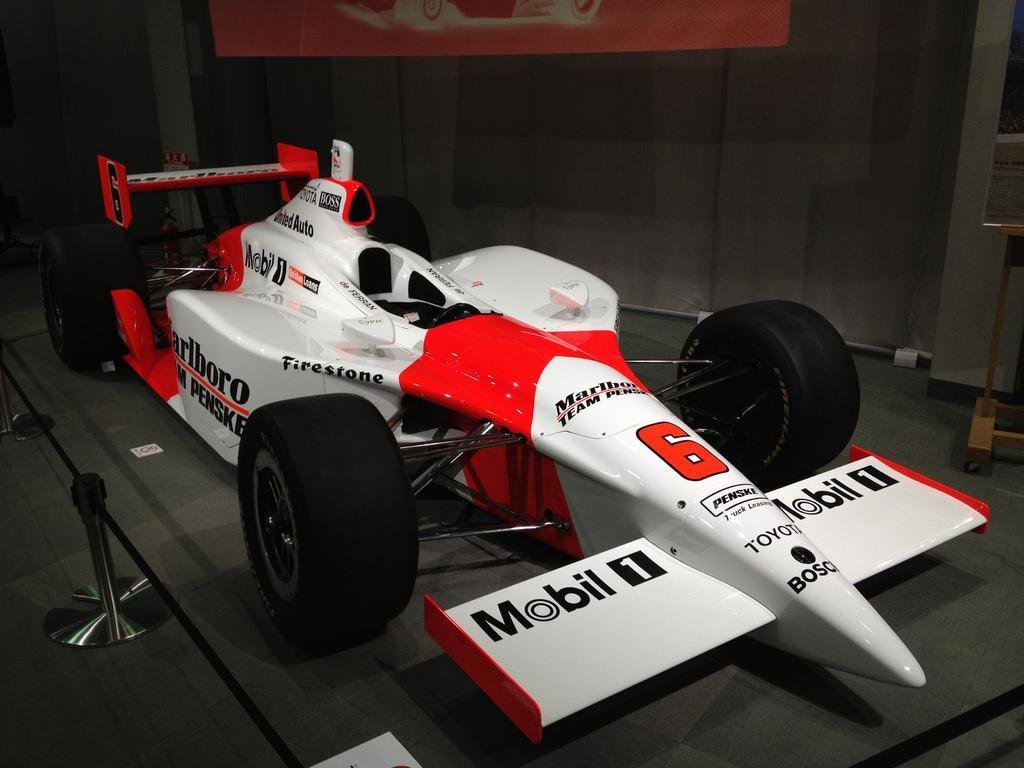In one or two sentences, can you explain what this image depicts? In this image I can see the sports car which is red, white and black in color on the floor. I can see few poles and a black colored ribbon to the poles. In the background I can see the wall and a red colored banner. 